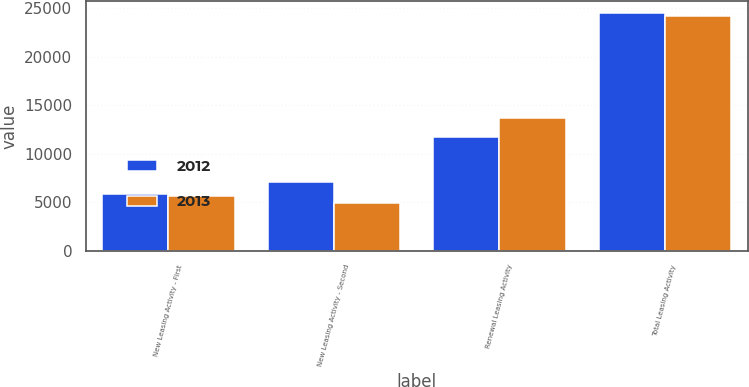<chart> <loc_0><loc_0><loc_500><loc_500><stacked_bar_chart><ecel><fcel>New Leasing Activity - First<fcel>New Leasing Activity - Second<fcel>Renewal Leasing Activity<fcel>Total Leasing Activity<nl><fcel>2012<fcel>5787<fcel>7019<fcel>11684<fcel>24490<nl><fcel>2013<fcel>5628<fcel>4911<fcel>13626<fcel>24165<nl></chart> 